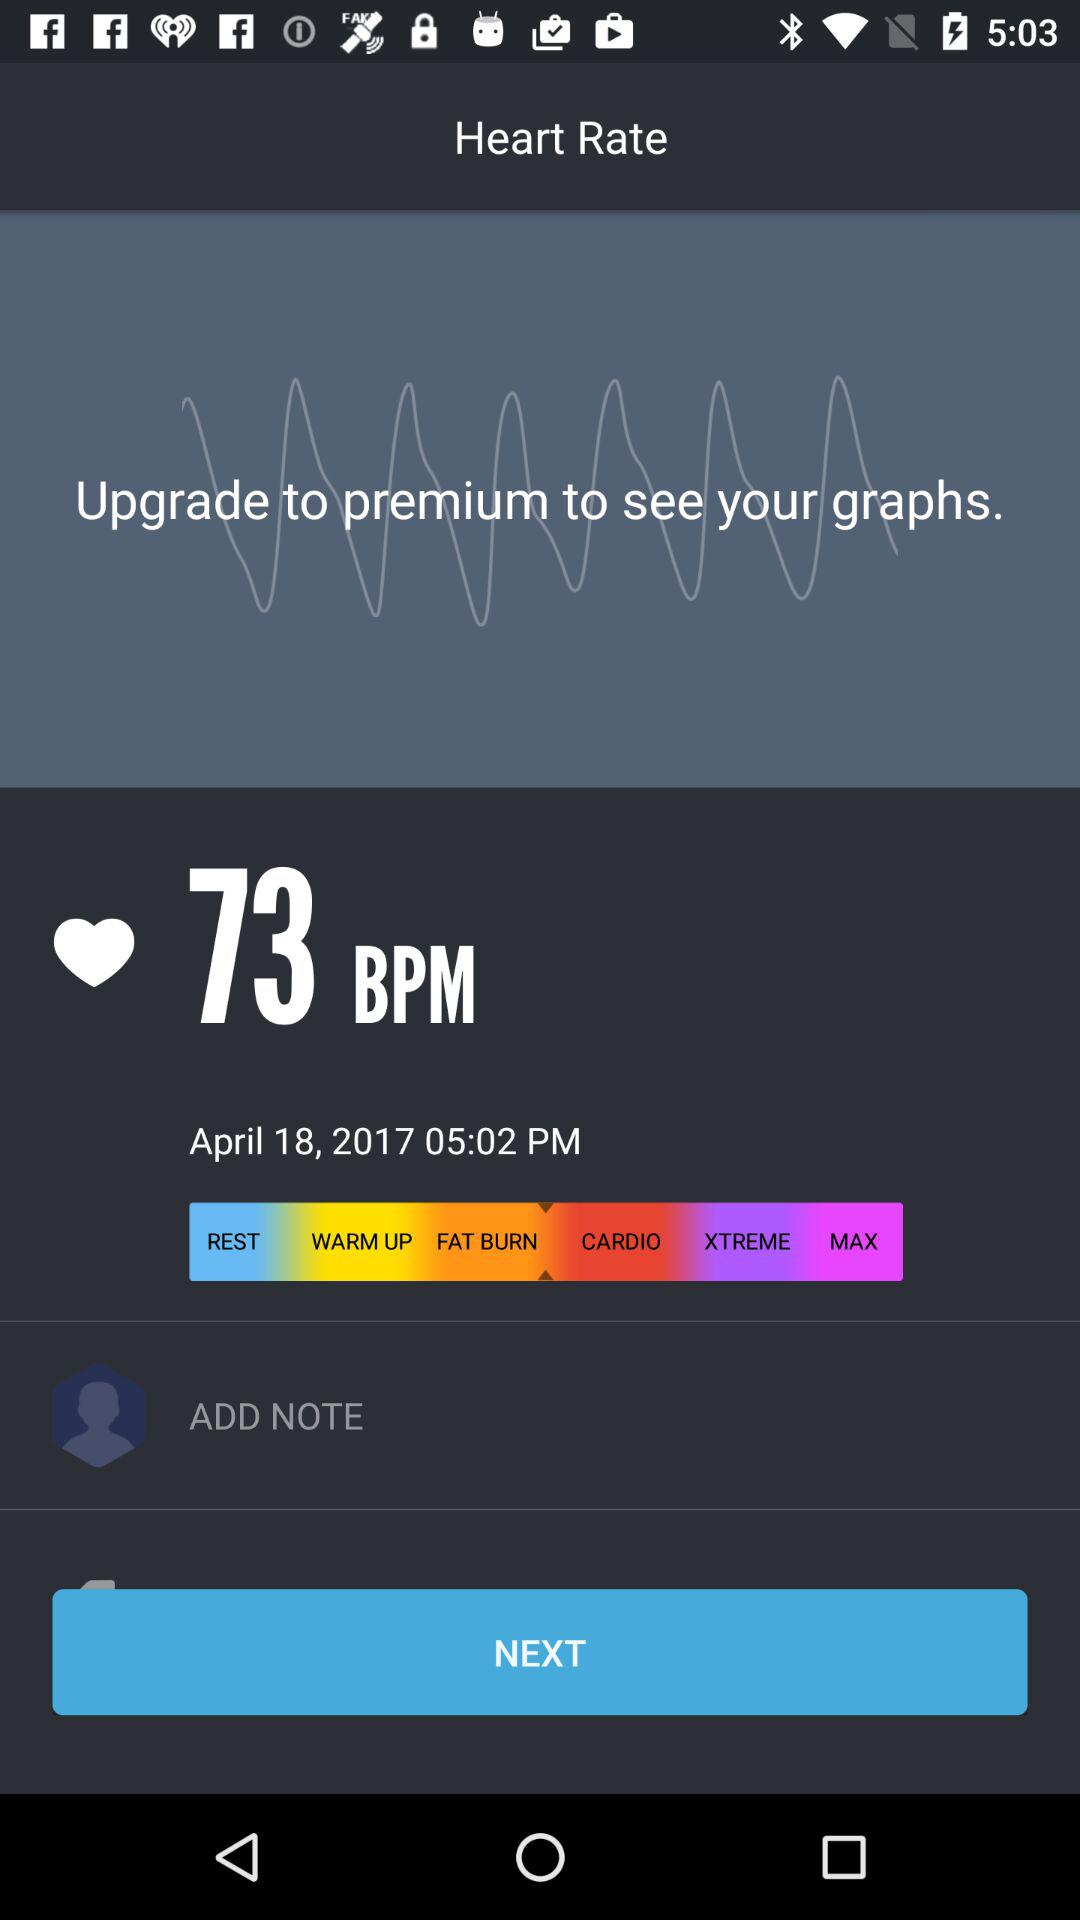What should I do to see graphs? You should upgrade to premium to see graphs. 